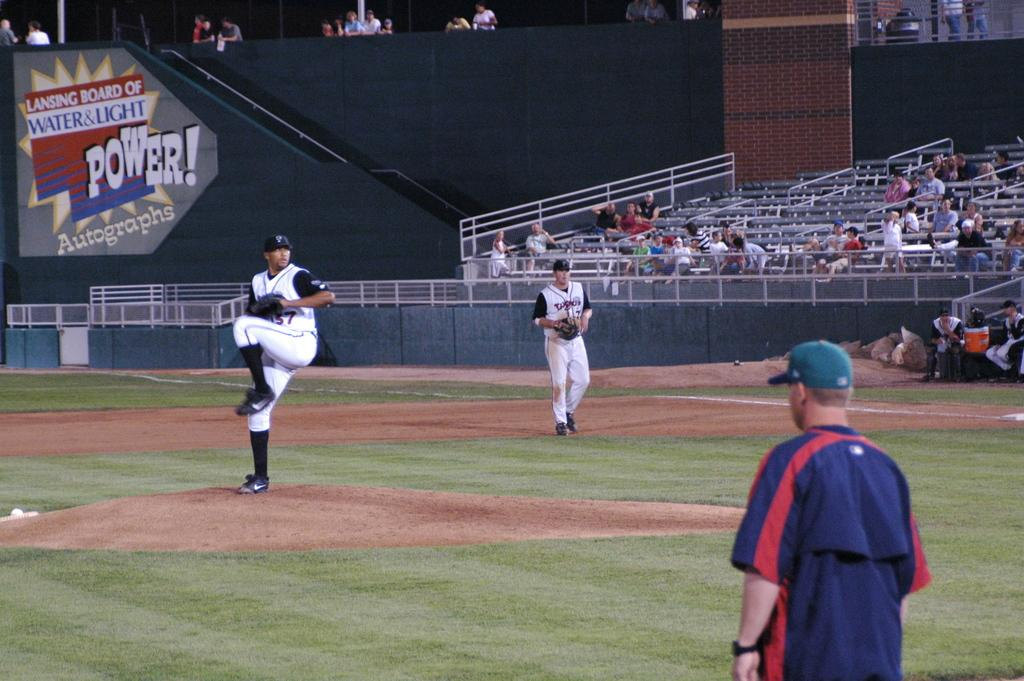<image>
Summarize the visual content of the image. An ad for Lansing Board of Water and Light can be seen behind the baseball field 